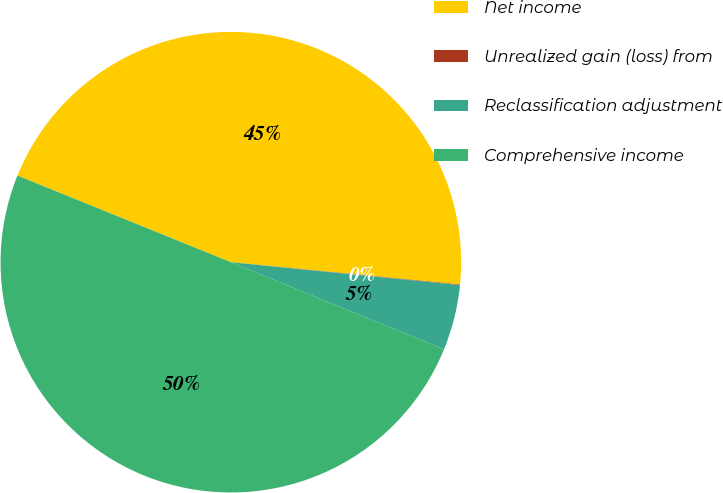Convert chart to OTSL. <chart><loc_0><loc_0><loc_500><loc_500><pie_chart><fcel>Net income<fcel>Unrealized gain (loss) from<fcel>Reclassification adjustment<fcel>Comprehensive income<nl><fcel>45.41%<fcel>0.04%<fcel>4.59%<fcel>49.96%<nl></chart> 